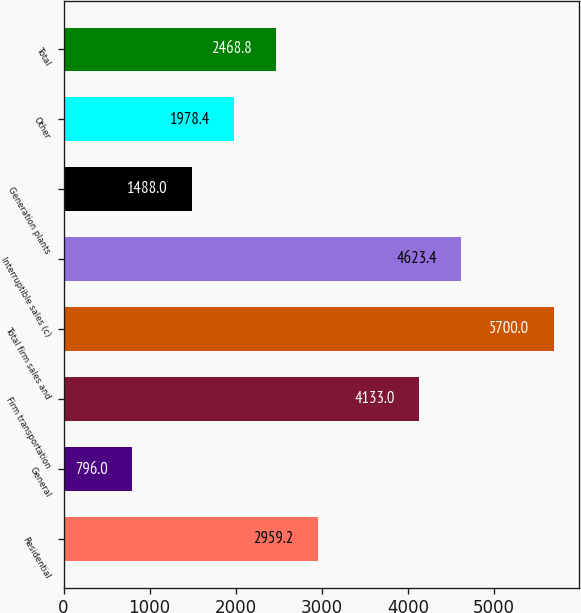Convert chart to OTSL. <chart><loc_0><loc_0><loc_500><loc_500><bar_chart><fcel>Residential<fcel>General<fcel>Firm transportation<fcel>Total firm sales and<fcel>Interruptible sales (c)<fcel>Generation plants<fcel>Other<fcel>Total<nl><fcel>2959.2<fcel>796<fcel>4133<fcel>5700<fcel>4623.4<fcel>1488<fcel>1978.4<fcel>2468.8<nl></chart> 